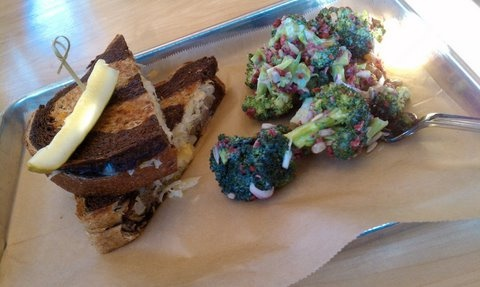Describe the objects in this image and their specific colors. I can see broccoli in tan, black, gray, darkgray, and teal tones, sandwich in tan, maroon, black, and gray tones, sandwich in tan, black, maroon, and gray tones, and spoon in tan, darkgray, and gray tones in this image. 